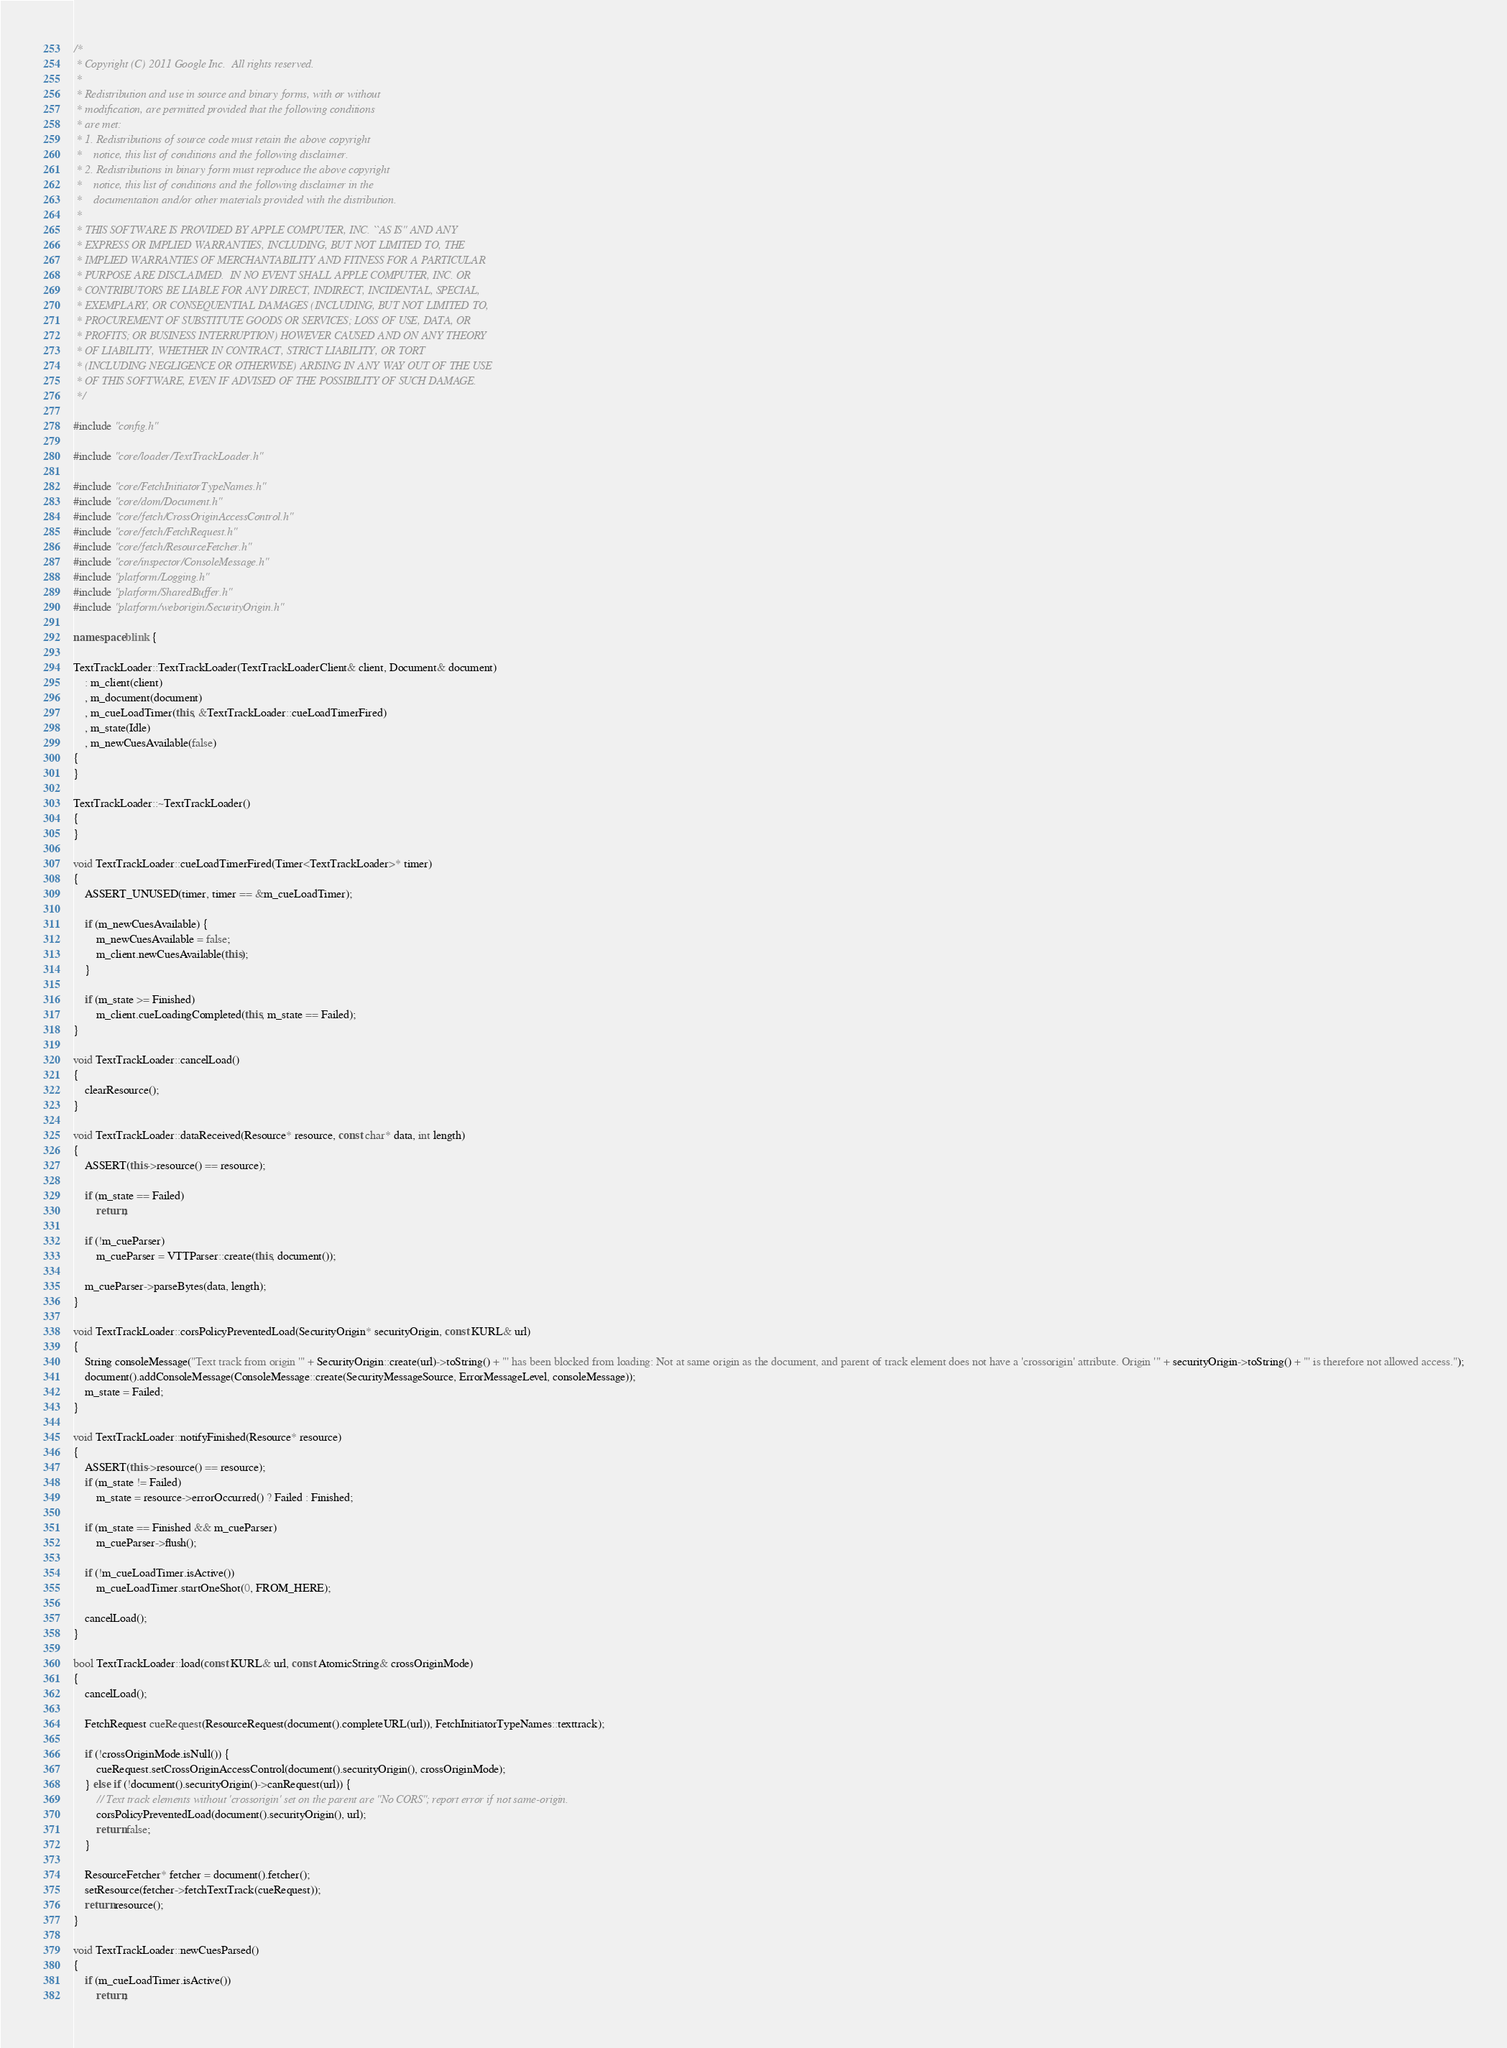Convert code to text. <code><loc_0><loc_0><loc_500><loc_500><_C++_>/*
 * Copyright (C) 2011 Google Inc.  All rights reserved.
 *
 * Redistribution and use in source and binary forms, with or without
 * modification, are permitted provided that the following conditions
 * are met:
 * 1. Redistributions of source code must retain the above copyright
 *    notice, this list of conditions and the following disclaimer.
 * 2. Redistributions in binary form must reproduce the above copyright
 *    notice, this list of conditions and the following disclaimer in the
 *    documentation and/or other materials provided with the distribution.
 *
 * THIS SOFTWARE IS PROVIDED BY APPLE COMPUTER, INC. ``AS IS'' AND ANY
 * EXPRESS OR IMPLIED WARRANTIES, INCLUDING, BUT NOT LIMITED TO, THE
 * IMPLIED WARRANTIES OF MERCHANTABILITY AND FITNESS FOR A PARTICULAR
 * PURPOSE ARE DISCLAIMED.  IN NO EVENT SHALL APPLE COMPUTER, INC. OR
 * CONTRIBUTORS BE LIABLE FOR ANY DIRECT, INDIRECT, INCIDENTAL, SPECIAL,
 * EXEMPLARY, OR CONSEQUENTIAL DAMAGES (INCLUDING, BUT NOT LIMITED TO,
 * PROCUREMENT OF SUBSTITUTE GOODS OR SERVICES; LOSS OF USE, DATA, OR
 * PROFITS; OR BUSINESS INTERRUPTION) HOWEVER CAUSED AND ON ANY THEORY
 * OF LIABILITY, WHETHER IN CONTRACT, STRICT LIABILITY, OR TORT
 * (INCLUDING NEGLIGENCE OR OTHERWISE) ARISING IN ANY WAY OUT OF THE USE
 * OF THIS SOFTWARE, EVEN IF ADVISED OF THE POSSIBILITY OF SUCH DAMAGE.
 */

#include "config.h"

#include "core/loader/TextTrackLoader.h"

#include "core/FetchInitiatorTypeNames.h"
#include "core/dom/Document.h"
#include "core/fetch/CrossOriginAccessControl.h"
#include "core/fetch/FetchRequest.h"
#include "core/fetch/ResourceFetcher.h"
#include "core/inspector/ConsoleMessage.h"
#include "platform/Logging.h"
#include "platform/SharedBuffer.h"
#include "platform/weborigin/SecurityOrigin.h"

namespace blink {

TextTrackLoader::TextTrackLoader(TextTrackLoaderClient& client, Document& document)
    : m_client(client)
    , m_document(document)
    , m_cueLoadTimer(this, &TextTrackLoader::cueLoadTimerFired)
    , m_state(Idle)
    , m_newCuesAvailable(false)
{
}

TextTrackLoader::~TextTrackLoader()
{
}

void TextTrackLoader::cueLoadTimerFired(Timer<TextTrackLoader>* timer)
{
    ASSERT_UNUSED(timer, timer == &m_cueLoadTimer);

    if (m_newCuesAvailable) {
        m_newCuesAvailable = false;
        m_client.newCuesAvailable(this);
    }

    if (m_state >= Finished)
        m_client.cueLoadingCompleted(this, m_state == Failed);
}

void TextTrackLoader::cancelLoad()
{
    clearResource();
}

void TextTrackLoader::dataReceived(Resource* resource, const char* data, int length)
{
    ASSERT(this->resource() == resource);

    if (m_state == Failed)
        return;

    if (!m_cueParser)
        m_cueParser = VTTParser::create(this, document());

    m_cueParser->parseBytes(data, length);
}

void TextTrackLoader::corsPolicyPreventedLoad(SecurityOrigin* securityOrigin, const KURL& url)
{
    String consoleMessage("Text track from origin '" + SecurityOrigin::create(url)->toString() + "' has been blocked from loading: Not at same origin as the document, and parent of track element does not have a 'crossorigin' attribute. Origin '" + securityOrigin->toString() + "' is therefore not allowed access.");
    document().addConsoleMessage(ConsoleMessage::create(SecurityMessageSource, ErrorMessageLevel, consoleMessage));
    m_state = Failed;
}

void TextTrackLoader::notifyFinished(Resource* resource)
{
    ASSERT(this->resource() == resource);
    if (m_state != Failed)
        m_state = resource->errorOccurred() ? Failed : Finished;

    if (m_state == Finished && m_cueParser)
        m_cueParser->flush();

    if (!m_cueLoadTimer.isActive())
        m_cueLoadTimer.startOneShot(0, FROM_HERE);

    cancelLoad();
}

bool TextTrackLoader::load(const KURL& url, const AtomicString& crossOriginMode)
{
    cancelLoad();

    FetchRequest cueRequest(ResourceRequest(document().completeURL(url)), FetchInitiatorTypeNames::texttrack);

    if (!crossOriginMode.isNull()) {
        cueRequest.setCrossOriginAccessControl(document().securityOrigin(), crossOriginMode);
    } else if (!document().securityOrigin()->canRequest(url)) {
        // Text track elements without 'crossorigin' set on the parent are "No CORS"; report error if not same-origin.
        corsPolicyPreventedLoad(document().securityOrigin(), url);
        return false;
    }

    ResourceFetcher* fetcher = document().fetcher();
    setResource(fetcher->fetchTextTrack(cueRequest));
    return resource();
}

void TextTrackLoader::newCuesParsed()
{
    if (m_cueLoadTimer.isActive())
        return;
</code> 